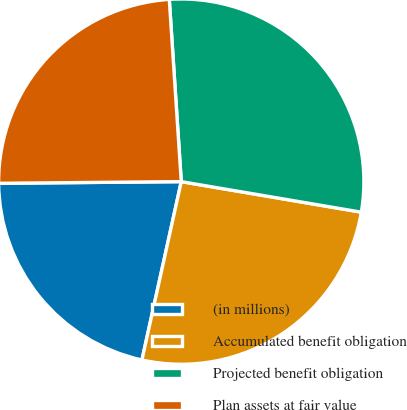<chart> <loc_0><loc_0><loc_500><loc_500><pie_chart><fcel>(in millions)<fcel>Accumulated benefit obligation<fcel>Projected benefit obligation<fcel>Plan assets at fair value<nl><fcel>21.4%<fcel>25.78%<fcel>28.72%<fcel>24.1%<nl></chart> 